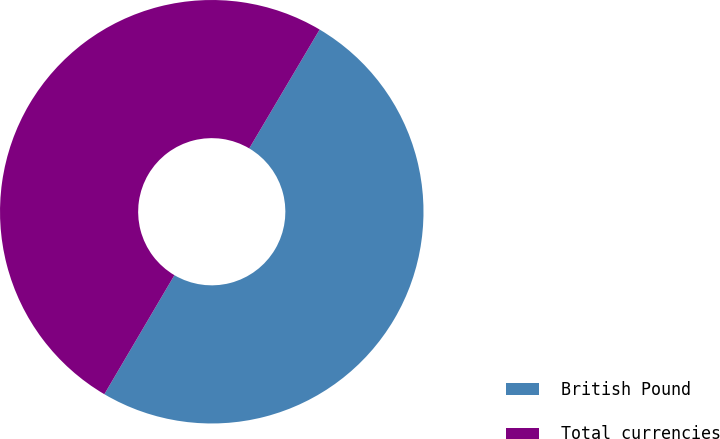<chart> <loc_0><loc_0><loc_500><loc_500><pie_chart><fcel>British Pound<fcel>Total currencies<nl><fcel>49.96%<fcel>50.04%<nl></chart> 